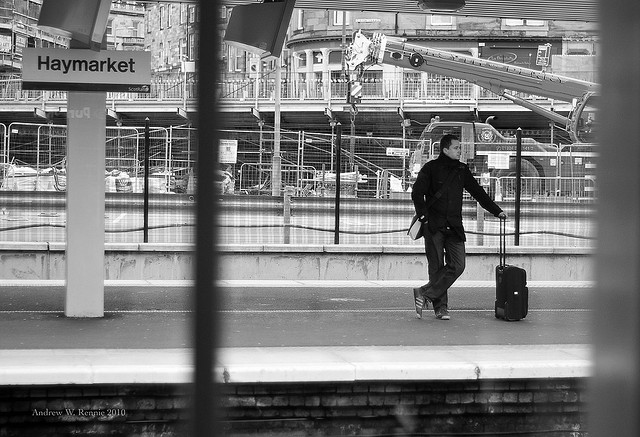Read all the text in this image. Haymarket 2010 Rennie W Andrew 